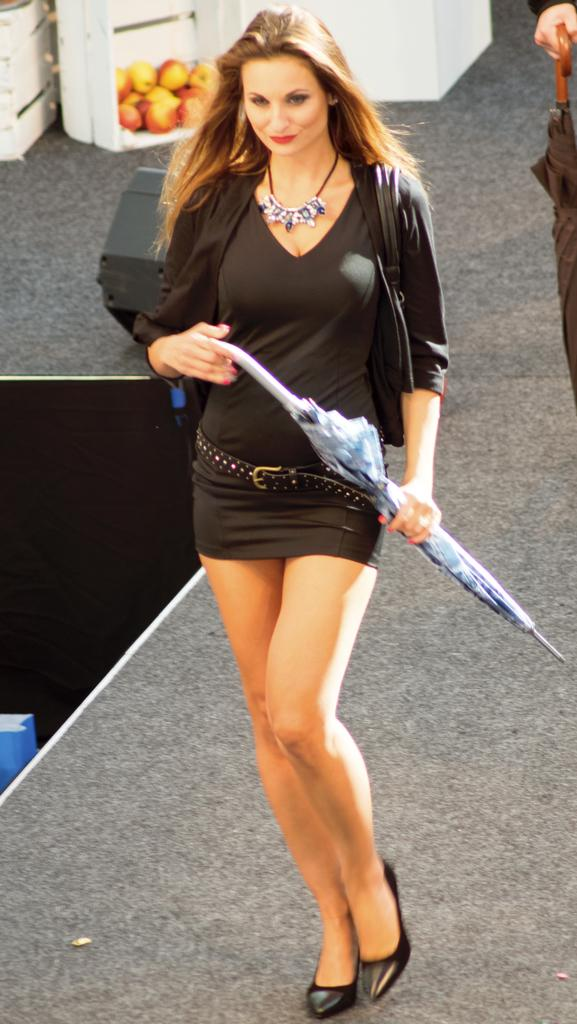What is the main subject of the image? The main subject of the image is a woman. What is the woman doing in the image? The woman is standing in the image. What object is the woman holding in the image? The woman is holding an umbrella in the image. What type of acoustics can be heard in the background of the image? There is no audible information in the image, so it is not possible to determine the acoustics. 